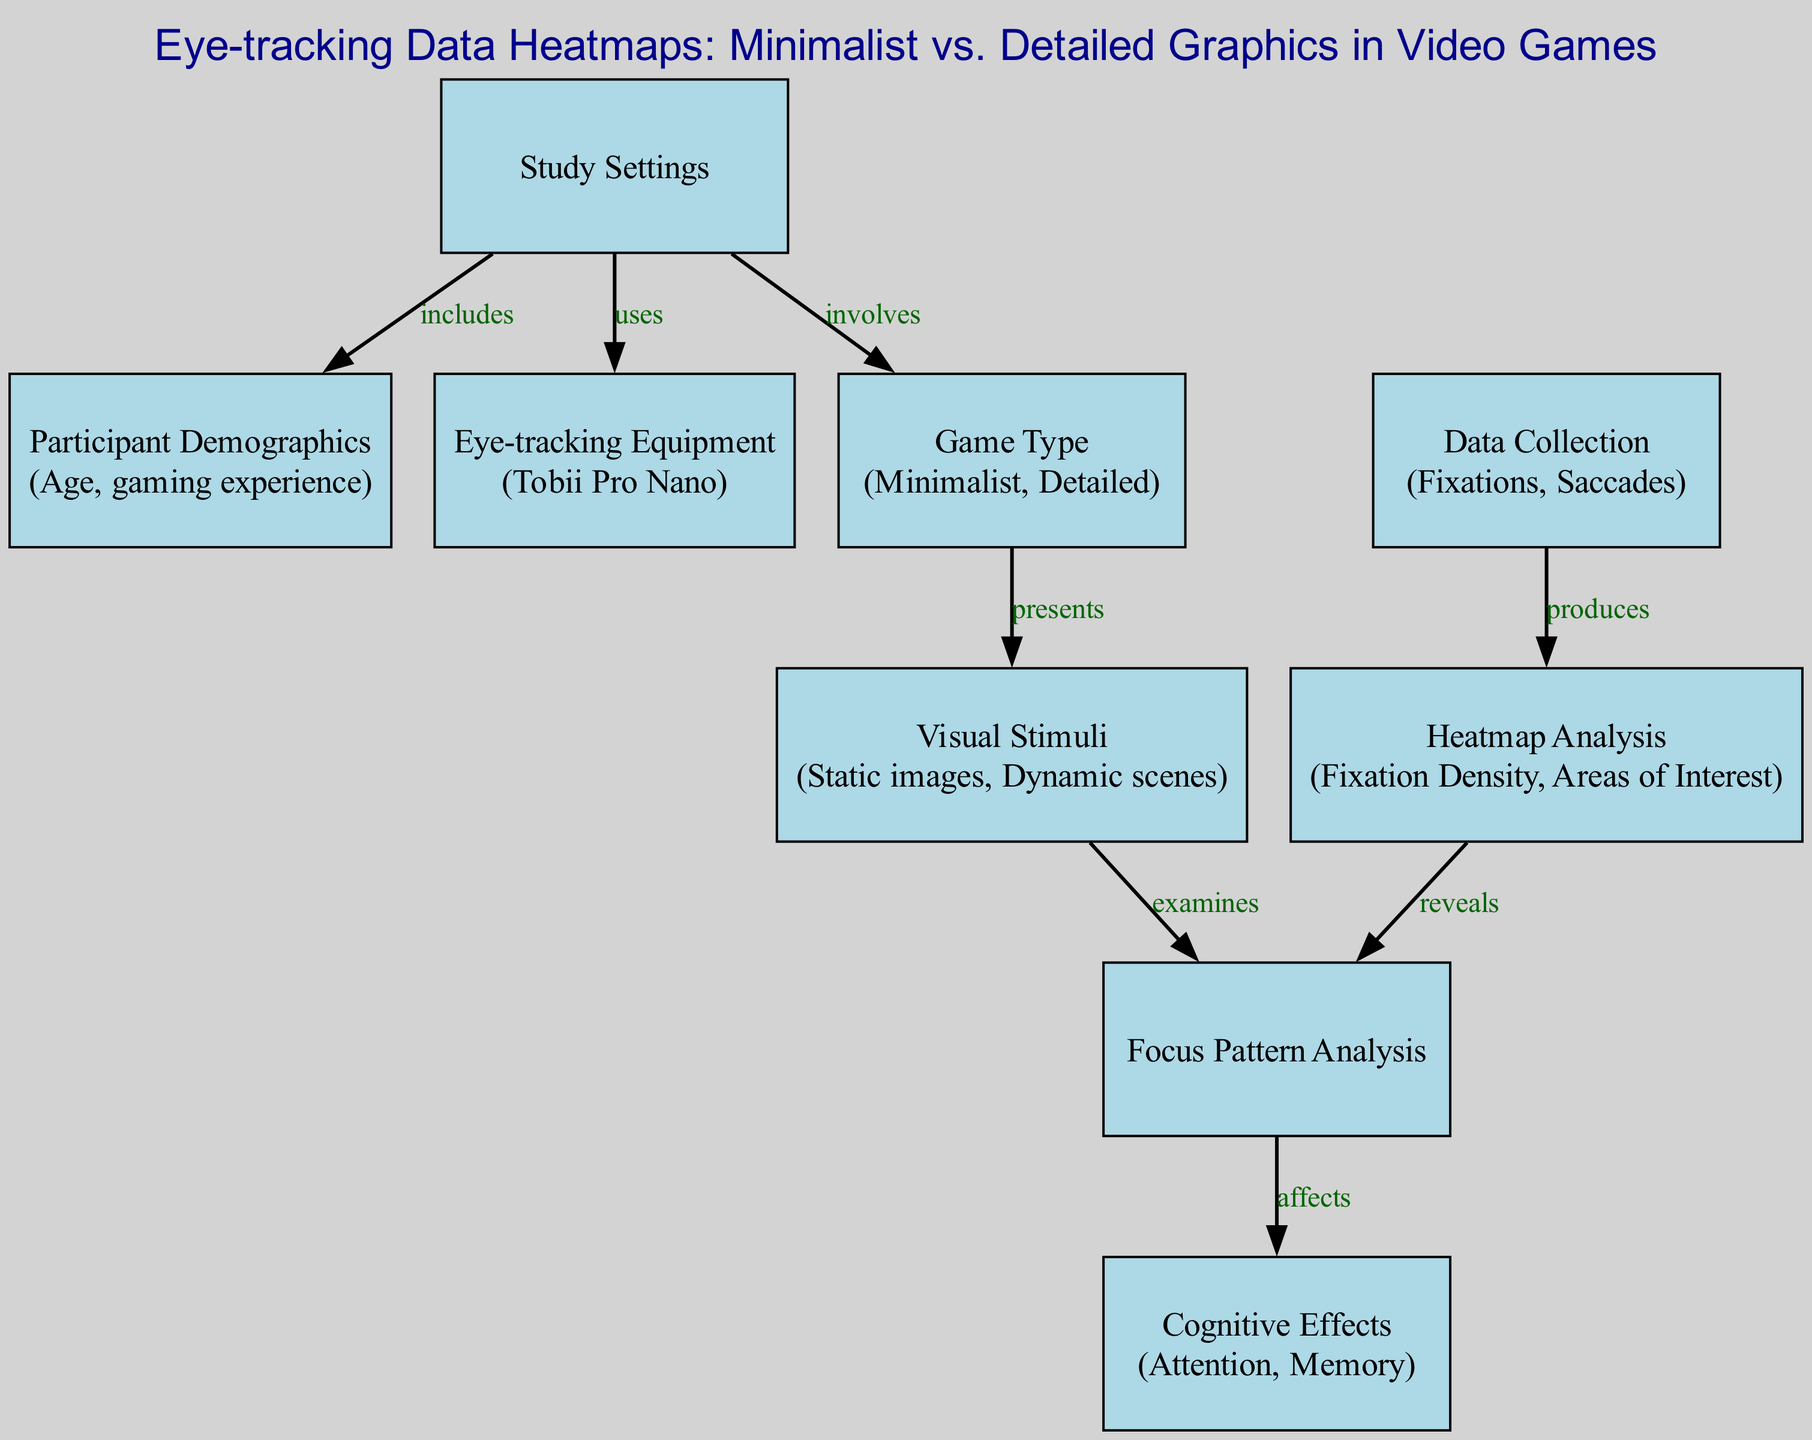What are the two game types examined in the study? The diagram includes "Minimalist" and "Detailed" under the "Game Type" node. By referring to the edge labeled "involves" connecting "Study Settings" to "Game Type," we see the relevant game types being focused on.
Answer: Minimalist, Detailed What equipment is used for eye-tracking? The diagram explicitly mentions the "Tobii Pro Nano" under the "Eye-tracking Equipment" node. This information can be found in the node and is clearly labeled.
Answer: Tobii Pro Nano How many nodes are present in the diagram? By counting the items listed under the "nodes" section of the diagram data, we find there are 9 distinct nodes. This is achieved by reviewing the structure of the diagram and summing the node entries.
Answer: 9 Which node is linked to "Heatmap Analysis"? Looking at the edges in the diagram, the edge that connects "Data Collection" to "Heatmap Analysis" indicates that "Data Collection" is the node linked to "Heatmap Analysis." This connection is mapped out through the directed edges.
Answer: Data Collection What cognitive effects are analyzed in the diagram? Under the "Cognitive Effects" node, it states "Attention, Memory." This can be identified directly from the final node where the analysis of cognitive effects occurs as a result of focus patterns.
Answer: Attention, Memory How does "Focus Pattern Analysis" relate to "Cognitive Effects"? According to the diagram, the edge labeled "affects" links "Focus Pattern Analysis" to "Cognitive Effects." This suggests that the findings from analyzing focus patterns directly influence or provide insights into cognitive effects.
Answer: affects What type of visual stimuli are involved in the study? The diagram states "Static images, Dynamic scenes" under the "Visual Stimuli" node. This information is readily available by referring directly to that specific node.
Answer: Static images, Dynamic scenes Which node provides information on participant demographics? The node labeled "Participant Demographics" directly provides this information. We can ascertain this by identifying the node's label in the diagram list.
Answer: Participant Demographics 